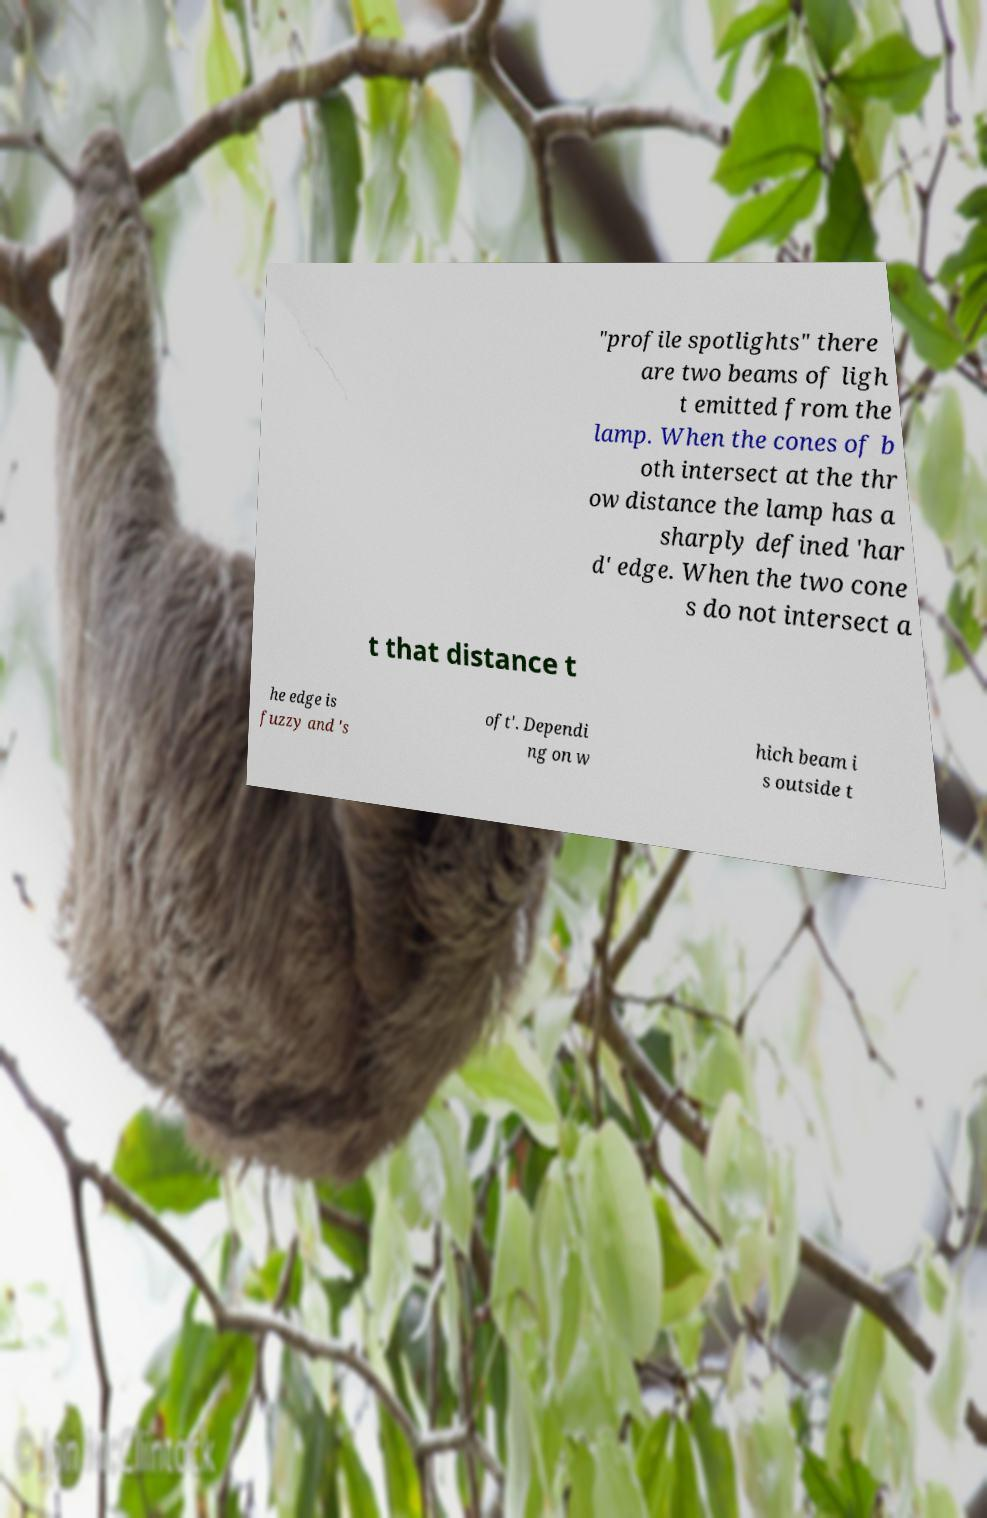Can you accurately transcribe the text from the provided image for me? "profile spotlights" there are two beams of ligh t emitted from the lamp. When the cones of b oth intersect at the thr ow distance the lamp has a sharply defined 'har d' edge. When the two cone s do not intersect a t that distance t he edge is fuzzy and 's oft'. Dependi ng on w hich beam i s outside t 